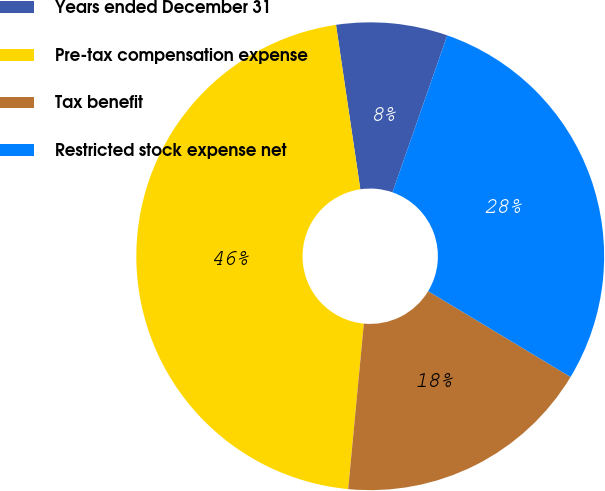Convert chart to OTSL. <chart><loc_0><loc_0><loc_500><loc_500><pie_chart><fcel>Years ended December 31<fcel>Pre-tax compensation expense<fcel>Tax benefit<fcel>Restricted stock expense net<nl><fcel>7.68%<fcel>46.16%<fcel>17.87%<fcel>28.29%<nl></chart> 